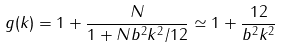Convert formula to latex. <formula><loc_0><loc_0><loc_500><loc_500>g ( k ) = 1 + \frac { N } { 1 + N b ^ { 2 } k ^ { 2 } / 1 2 } \simeq 1 + \frac { 1 2 } { b ^ { 2 } k ^ { 2 } }</formula> 